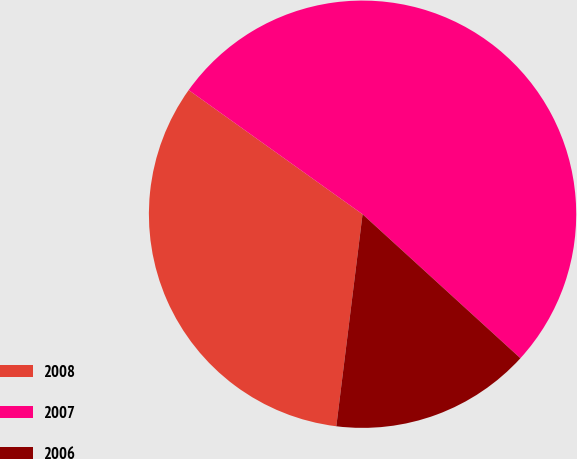Convert chart to OTSL. <chart><loc_0><loc_0><loc_500><loc_500><pie_chart><fcel>2008<fcel>2007<fcel>2006<nl><fcel>32.91%<fcel>51.9%<fcel>15.19%<nl></chart> 